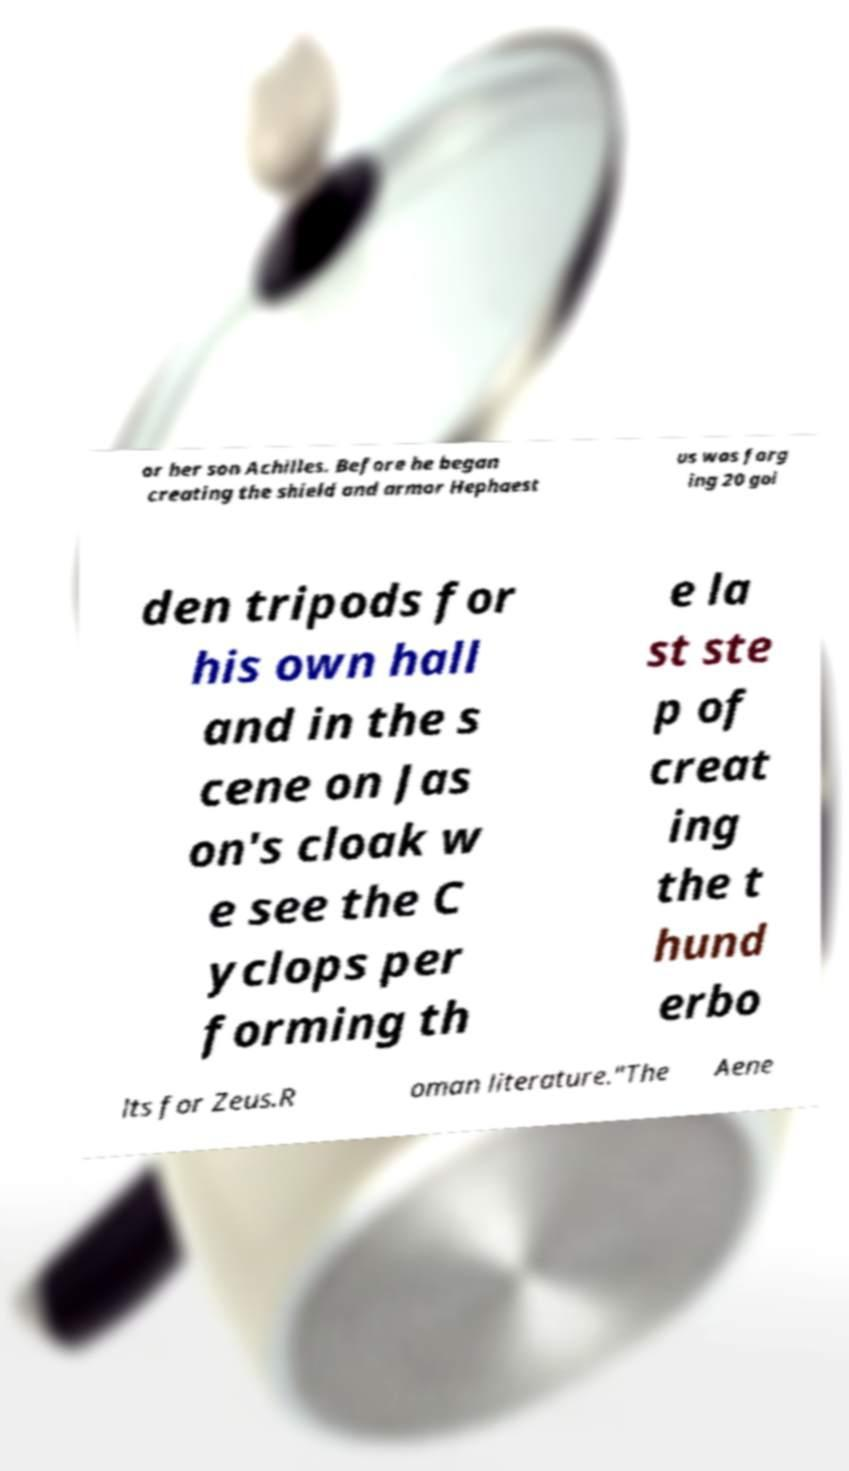There's text embedded in this image that I need extracted. Can you transcribe it verbatim? or her son Achilles. Before he began creating the shield and armor Hephaest us was forg ing 20 gol den tripods for his own hall and in the s cene on Jas on's cloak w e see the C yclops per forming th e la st ste p of creat ing the t hund erbo lts for Zeus.R oman literature."The Aene 